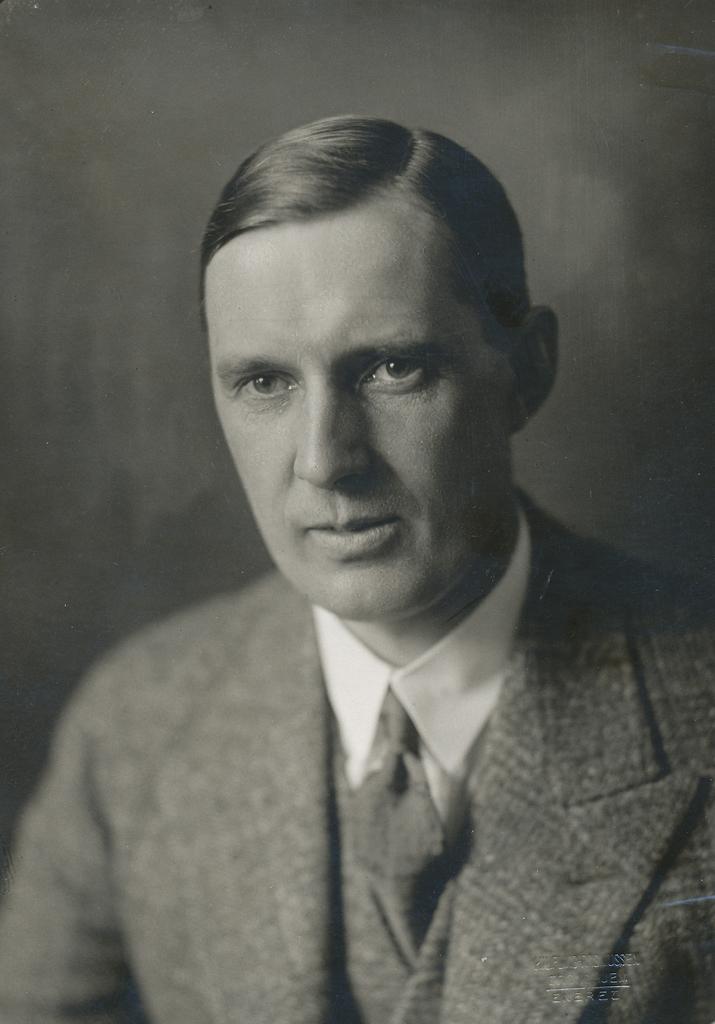Describe this image in one or two sentences. This is a black and white image. In this image we can see a man. Also there is watermark in the right bottom corner. 